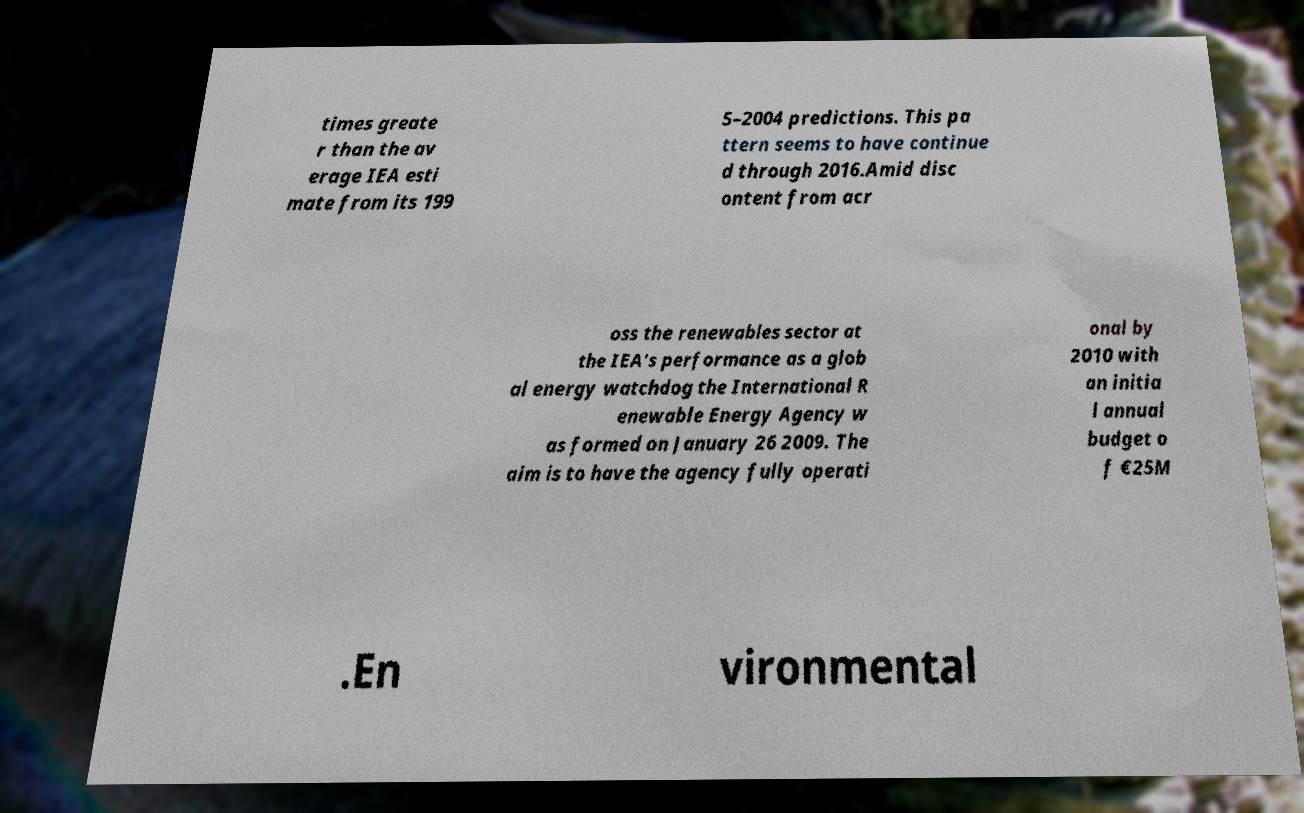Please identify and transcribe the text found in this image. times greate r than the av erage IEA esti mate from its 199 5–2004 predictions. This pa ttern seems to have continue d through 2016.Amid disc ontent from acr oss the renewables sector at the IEA's performance as a glob al energy watchdog the International R enewable Energy Agency w as formed on January 26 2009. The aim is to have the agency fully operati onal by 2010 with an initia l annual budget o f €25M .En vironmental 